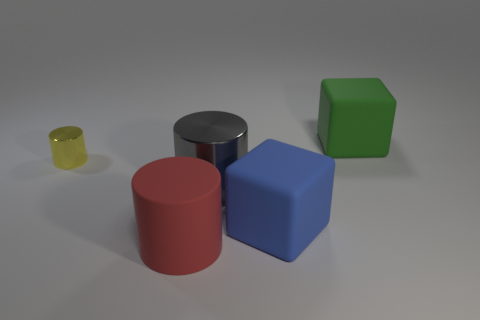Add 3 small matte blocks. How many objects exist? 8 Subtract all blocks. How many objects are left? 3 Add 3 big purple cylinders. How many big purple cylinders exist? 3 Subtract 0 gray cubes. How many objects are left? 5 Subtract all large green blocks. Subtract all balls. How many objects are left? 4 Add 4 blue cubes. How many blue cubes are left? 5 